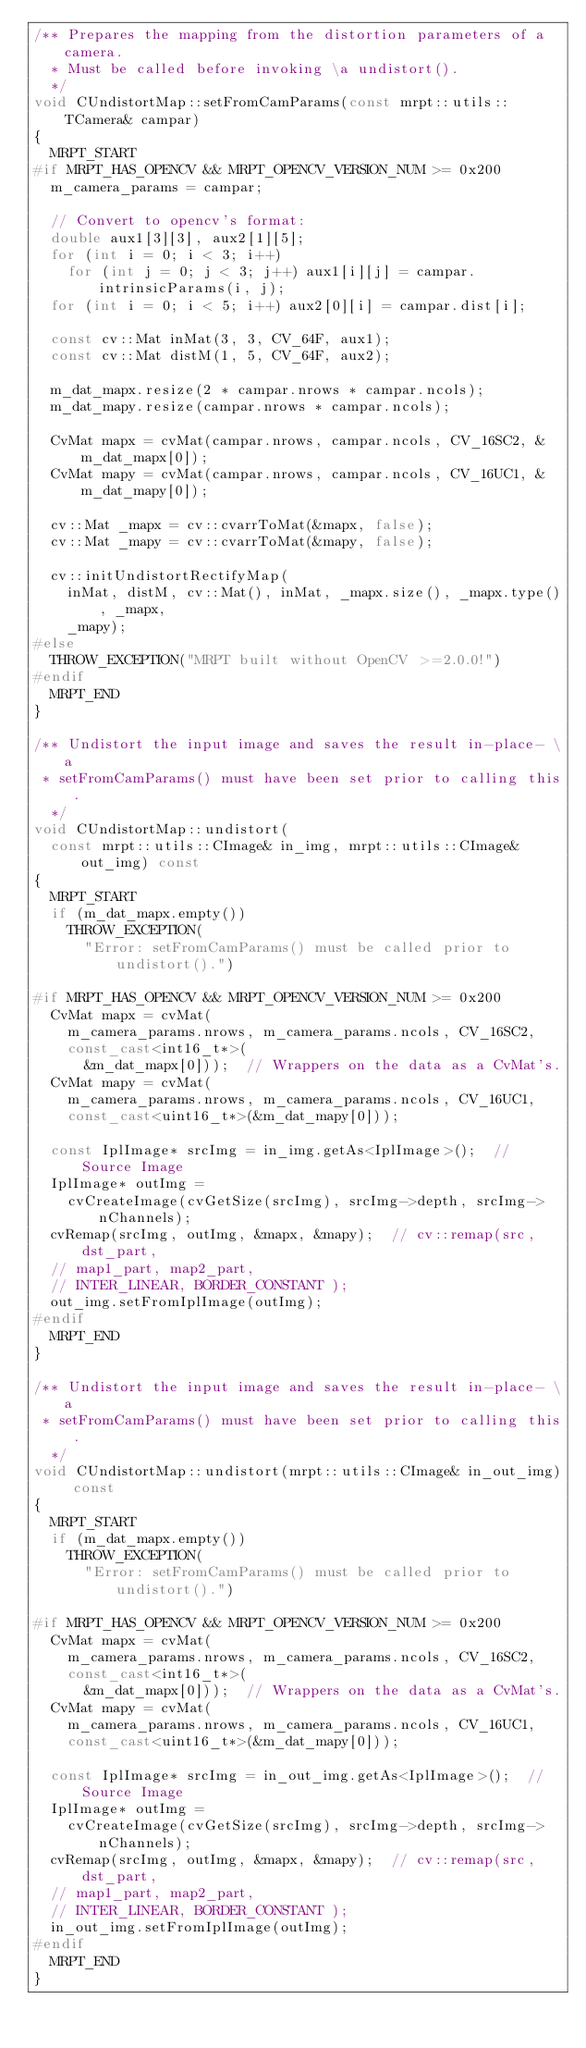Convert code to text. <code><loc_0><loc_0><loc_500><loc_500><_C++_>/** Prepares the mapping from the distortion parameters of a camera.
  * Must be called before invoking \a undistort().
  */
void CUndistortMap::setFromCamParams(const mrpt::utils::TCamera& campar)
{
	MRPT_START
#if MRPT_HAS_OPENCV && MRPT_OPENCV_VERSION_NUM >= 0x200
	m_camera_params = campar;

	// Convert to opencv's format:
	double aux1[3][3], aux2[1][5];
	for (int i = 0; i < 3; i++)
		for (int j = 0; j < 3; j++) aux1[i][j] = campar.intrinsicParams(i, j);
	for (int i = 0; i < 5; i++) aux2[0][i] = campar.dist[i];

	const cv::Mat inMat(3, 3, CV_64F, aux1);
	const cv::Mat distM(1, 5, CV_64F, aux2);

	m_dat_mapx.resize(2 * campar.nrows * campar.ncols);
	m_dat_mapy.resize(campar.nrows * campar.ncols);

	CvMat mapx = cvMat(campar.nrows, campar.ncols, CV_16SC2, &m_dat_mapx[0]);
	CvMat mapy = cvMat(campar.nrows, campar.ncols, CV_16UC1, &m_dat_mapy[0]);

	cv::Mat _mapx = cv::cvarrToMat(&mapx, false);
	cv::Mat _mapy = cv::cvarrToMat(&mapy, false);

	cv::initUndistortRectifyMap(
		inMat, distM, cv::Mat(), inMat, _mapx.size(), _mapx.type(), _mapx,
		_mapy);
#else
	THROW_EXCEPTION("MRPT built without OpenCV >=2.0.0!")
#endif
	MRPT_END
}

/** Undistort the input image and saves the result in-place- \a
 * setFromCamParams() must have been set prior to calling this.
  */
void CUndistortMap::undistort(
	const mrpt::utils::CImage& in_img, mrpt::utils::CImage& out_img) const
{
	MRPT_START
	if (m_dat_mapx.empty())
		THROW_EXCEPTION(
			"Error: setFromCamParams() must be called prior to undistort().")

#if MRPT_HAS_OPENCV && MRPT_OPENCV_VERSION_NUM >= 0x200
	CvMat mapx = cvMat(
		m_camera_params.nrows, m_camera_params.ncols, CV_16SC2,
		const_cast<int16_t*>(
			&m_dat_mapx[0]));  // Wrappers on the data as a CvMat's.
	CvMat mapy = cvMat(
		m_camera_params.nrows, m_camera_params.ncols, CV_16UC1,
		const_cast<uint16_t*>(&m_dat_mapy[0]));

	const IplImage* srcImg = in_img.getAs<IplImage>();  // Source Image
	IplImage* outImg =
		cvCreateImage(cvGetSize(srcImg), srcImg->depth, srcImg->nChannels);
	cvRemap(srcImg, outImg, &mapx, &mapy);  // cv::remap(src, dst_part,
	// map1_part, map2_part,
	// INTER_LINEAR, BORDER_CONSTANT );
	out_img.setFromIplImage(outImg);
#endif
	MRPT_END
}

/** Undistort the input image and saves the result in-place- \a
 * setFromCamParams() must have been set prior to calling this.
  */
void CUndistortMap::undistort(mrpt::utils::CImage& in_out_img) const
{
	MRPT_START
	if (m_dat_mapx.empty())
		THROW_EXCEPTION(
			"Error: setFromCamParams() must be called prior to undistort().")

#if MRPT_HAS_OPENCV && MRPT_OPENCV_VERSION_NUM >= 0x200
	CvMat mapx = cvMat(
		m_camera_params.nrows, m_camera_params.ncols, CV_16SC2,
		const_cast<int16_t*>(
			&m_dat_mapx[0]));  // Wrappers on the data as a CvMat's.
	CvMat mapy = cvMat(
		m_camera_params.nrows, m_camera_params.ncols, CV_16UC1,
		const_cast<uint16_t*>(&m_dat_mapy[0]));

	const IplImage* srcImg = in_out_img.getAs<IplImage>();  // Source Image
	IplImage* outImg =
		cvCreateImage(cvGetSize(srcImg), srcImg->depth, srcImg->nChannels);
	cvRemap(srcImg, outImg, &mapx, &mapy);  // cv::remap(src, dst_part,
	// map1_part, map2_part,
	// INTER_LINEAR, BORDER_CONSTANT );
	in_out_img.setFromIplImage(outImg);
#endif
	MRPT_END
}
</code> 